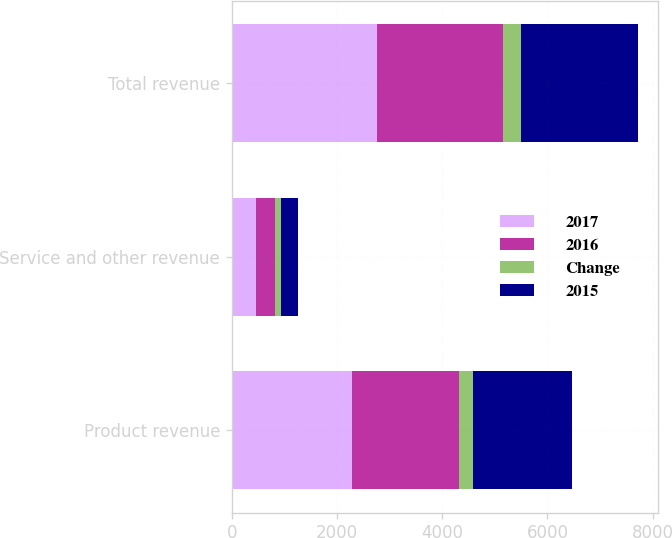<chart> <loc_0><loc_0><loc_500><loc_500><stacked_bar_chart><ecel><fcel>Product revenue<fcel>Service and other revenue<fcel>Total revenue<nl><fcel>2017<fcel>2289<fcel>463<fcel>2752<nl><fcel>2016<fcel>2032<fcel>366<fcel>2398<nl><fcel>Change<fcel>257<fcel>97<fcel>354<nl><fcel>2015<fcel>1891<fcel>329<fcel>2220<nl></chart> 